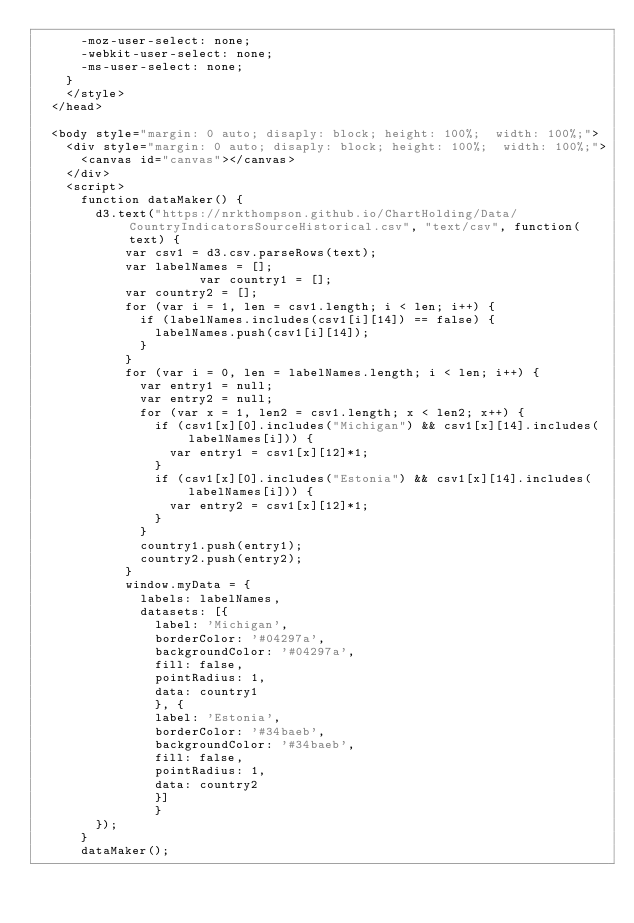Convert code to text. <code><loc_0><loc_0><loc_500><loc_500><_HTML_>			-moz-user-select: none;
			-webkit-user-select: none;
			-ms-user-select: none;
		}
		</style>
	</head>

	<body style="margin: 0 auto; disaply: block; height: 100%;  width: 100%;">
		<div style="margin: 0 auto; disaply: block; height: 100%;  width: 100%;">
			<canvas id="canvas"></canvas>
		</div>
		<script>
			function dataMaker() {
				d3.text("https://nrkthompson.github.io/ChartHolding/Data/CountryIndicatorsSourceHistorical.csv", "text/csv", function(text) {
					  var csv1 = d3.csv.parseRows(text);
					  var labelNames = [];
            				  var country1 = [];
					  var country2 = [];
					  for (var i = 1, len = csv1.length; i < len; i++) {
						  if (labelNames.includes(csv1[i][14]) == false) {
							  labelNames.push(csv1[i][14]);
						  }
					  }
					  for (var i = 0, len = labelNames.length; i < len; i++) {
						  var entry1 = null;
						  var entry2 = null;
						  for (var x = 1, len2 = csv1.length; x < len2; x++) {
							  if (csv1[x][0].includes("Michigan") && csv1[x][14].includes(labelNames[i])) {
								  var entry1 = csv1[x][12]*1;
							  }
							  if (csv1[x][0].includes("Estonia") && csv1[x][14].includes(labelNames[i])) {
								  var entry2 = csv1[x][12]*1;
							  }
						  }
						  country1.push(entry1);
						  country2.push(entry2);
					  }
					  window.myData = {
						  labels: labelNames,
						  datasets: [{
						    label: 'Michigan',
						    borderColor: '#04297a',
						    backgroundColor: '#04297a',
						    fill: false,
						    pointRadius: 1,
						    data: country1
						    }, {
						    label: 'Estonia',
						    borderColor: '#34baeb',
						    backgroundColor: '#34baeb',
						    fill: false,
						    pointRadius: 1,
						    data: country2
						    }]
						    }  
				});
			}
			dataMaker();</code> 